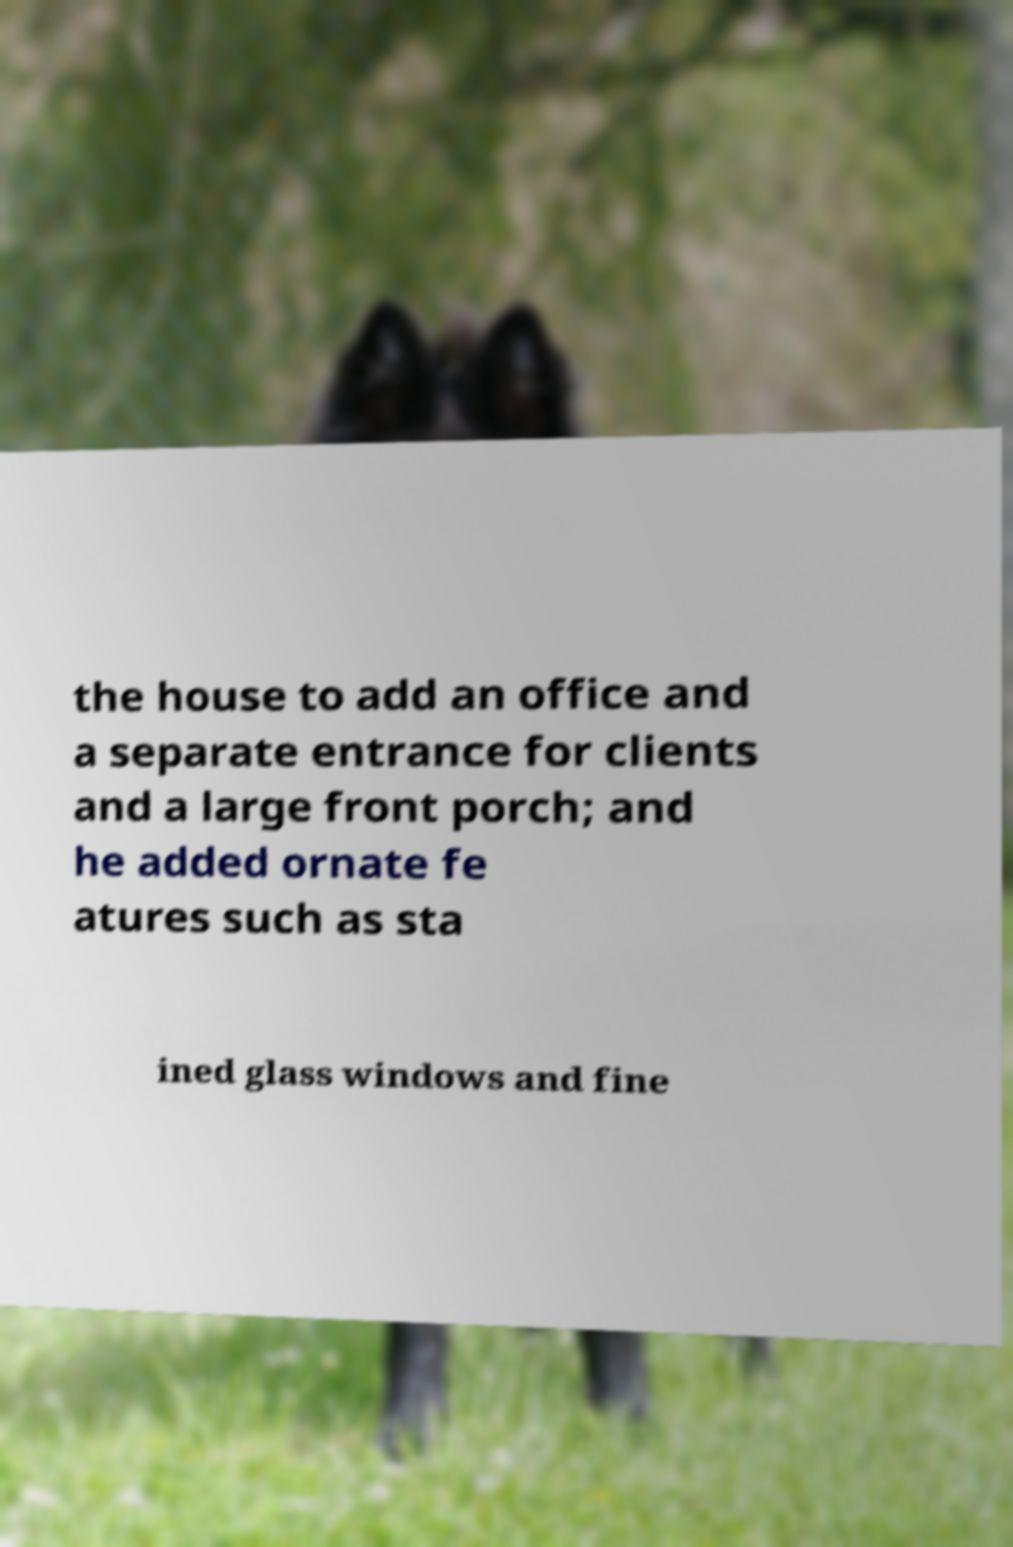Can you read and provide the text displayed in the image?This photo seems to have some interesting text. Can you extract and type it out for me? the house to add an office and a separate entrance for clients and a large front porch; and he added ornate fe atures such as sta ined glass windows and fine 